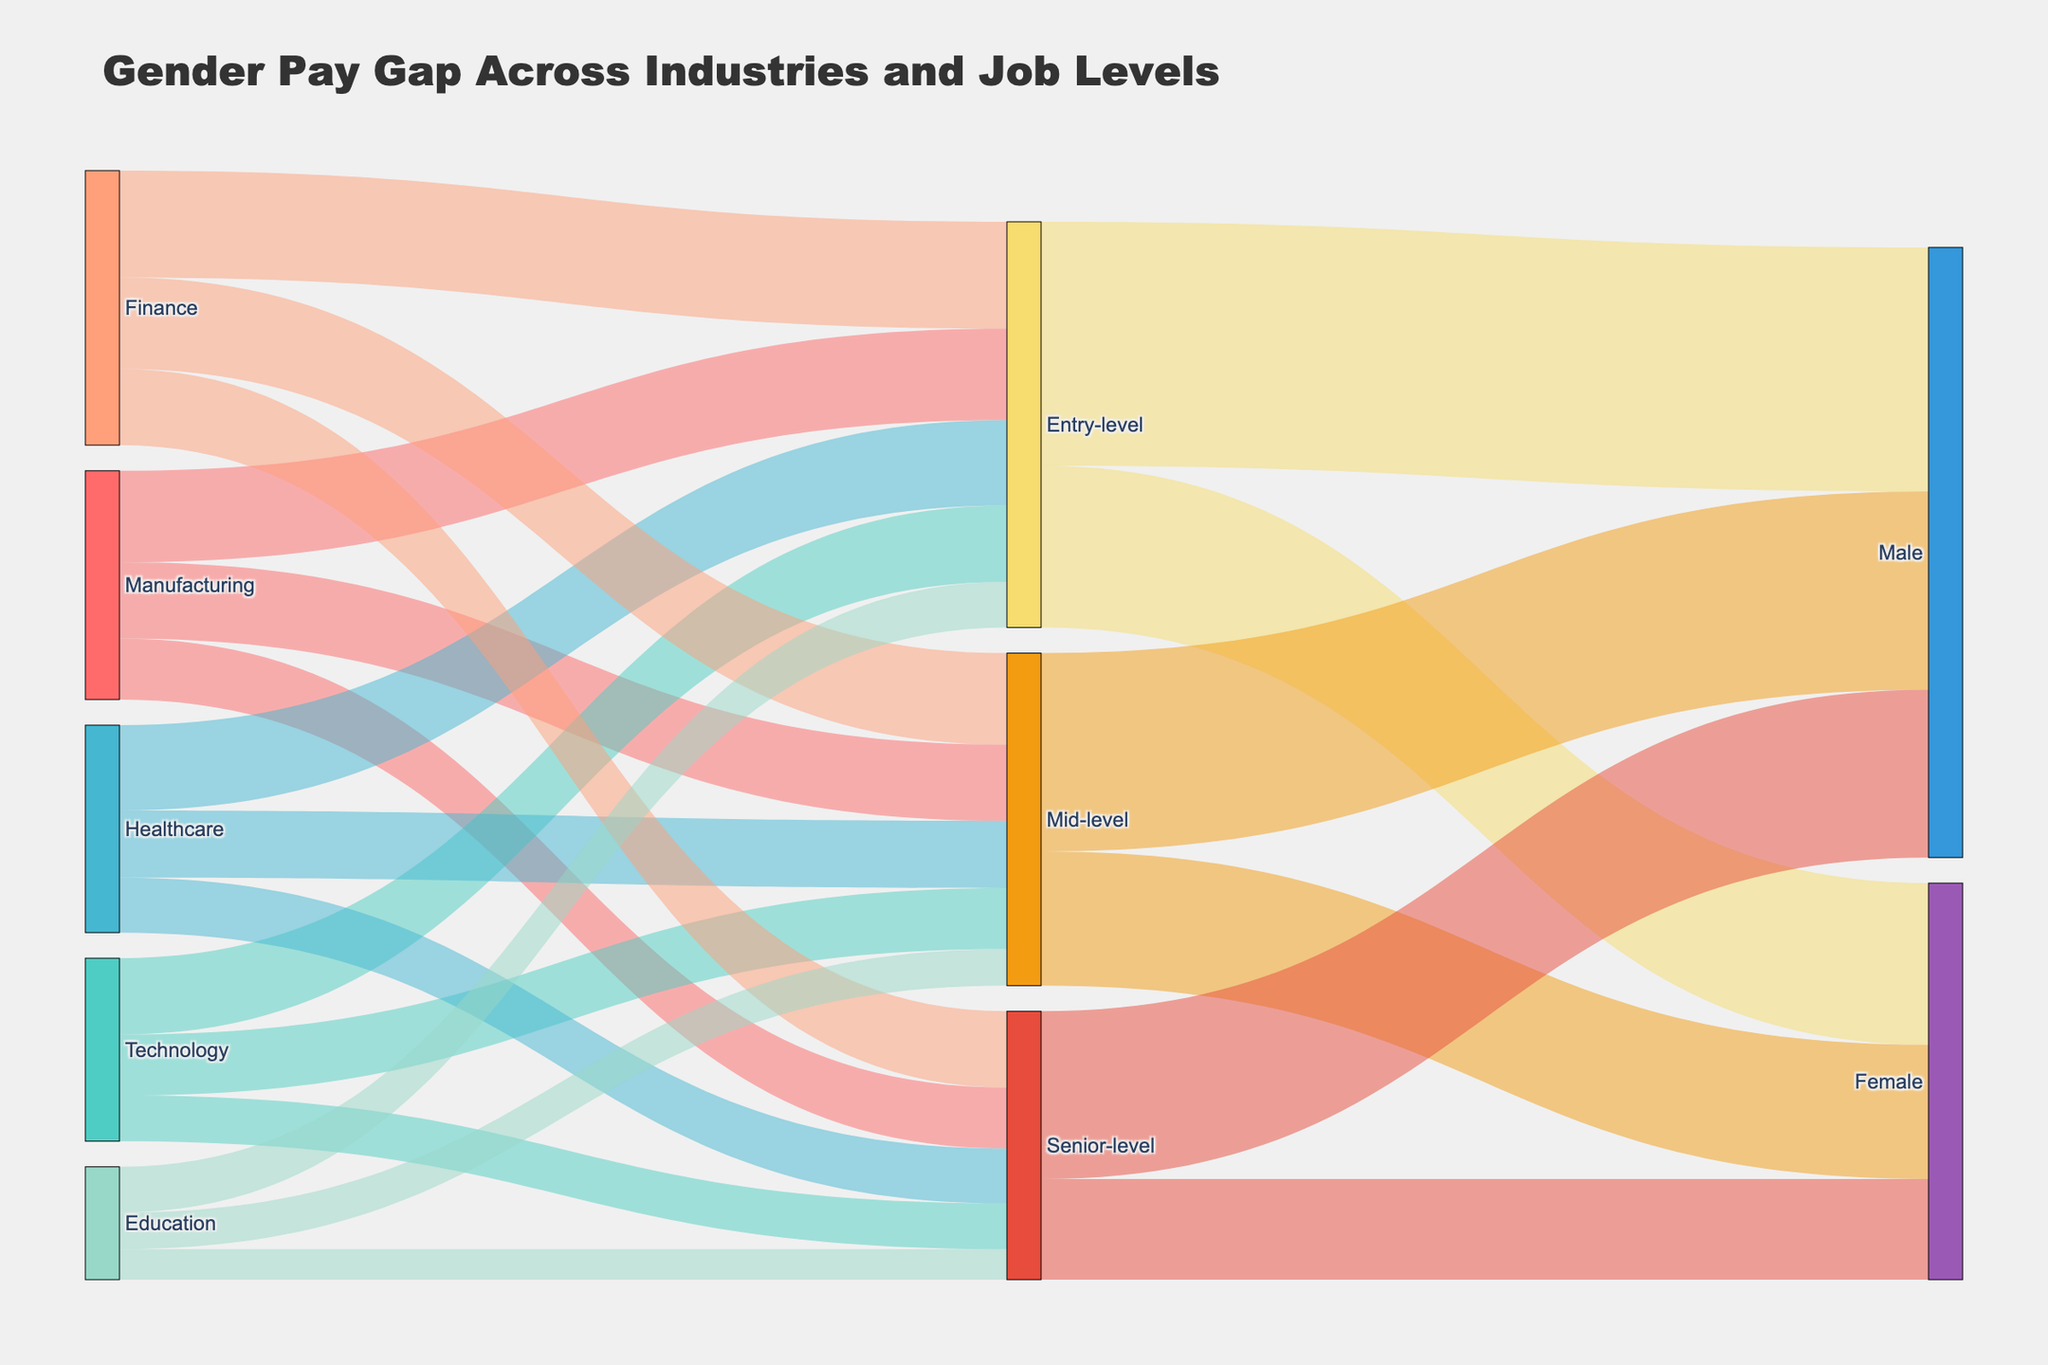What's the title of the figure? The title is usually placed at the top center of the figure. Here, it reads "Gender Pay Gap Across Industries and Job Levels".
Answer: Gender Pay Gap Across Industries and Job Levels Which industry has the largest number of entry-level positions? By looking at the size of the flow from industries to entry-level positions, Finance has the largest number with a value of 35.
Answer: Finance How many total entry-level positions are there across all industries? Sum the values of entry-level positions from all industries: 30 (Manufacturing) + 25 (Technology) + 28 (Healthcare) + 35 (Finance) + 15 (Education) = 133.
Answer: 133 Which job level has the highest number of positions for females? By assessing the size of the flow from job levels to females, entry-level has the highest number with a value of 53.
Answer: Entry-level Compare the number of mid-level positions in Technology versus Healthcare. The flow to mid-level positions from Technology is 20 and from Healthcare is 22. 22 is greater than 20.
Answer: Healthcare has more mid-level positions than Technology How do the number of positions in Manufacturing compare across job levels? Add up positions in each job level for Manufacturing: 30 (entry-level) + 25 (mid-level) + 20 (senior-level). Entry-level has the highest, followed by mid-level, and then senior-level.
Answer: Entry-level > Mid-level > Senior-level What is the total number of male positions across all job levels? Sum the values targeting males: 80 (entry-level) + 65 (mid-level) + 55 (senior-level) = 200.
Answer: 200 Which job level shows the greatest gender discrepancy in positions? Calculate the absolute differences: Entry-level (80 - 53 = 27), Mid-level (65 - 44 = 21), Senior-level (55 - 33 = 22). The entry-level shows the largest discrepancy.
Answer: Entry-level Which industry feeds the most senior-level positions? By evaluating the sizes of flows towards senior-level, Finance leads with 25 positions.
Answer: Finance What is the average number of female positions per job level? Sum the female positions: 53 (entry-level) + 44 (mid-level) + 33 (senior-level) = 130; divide by the number of job levels 130 / 3 ≈ 43.33.
Answer: Approximately 43.33 